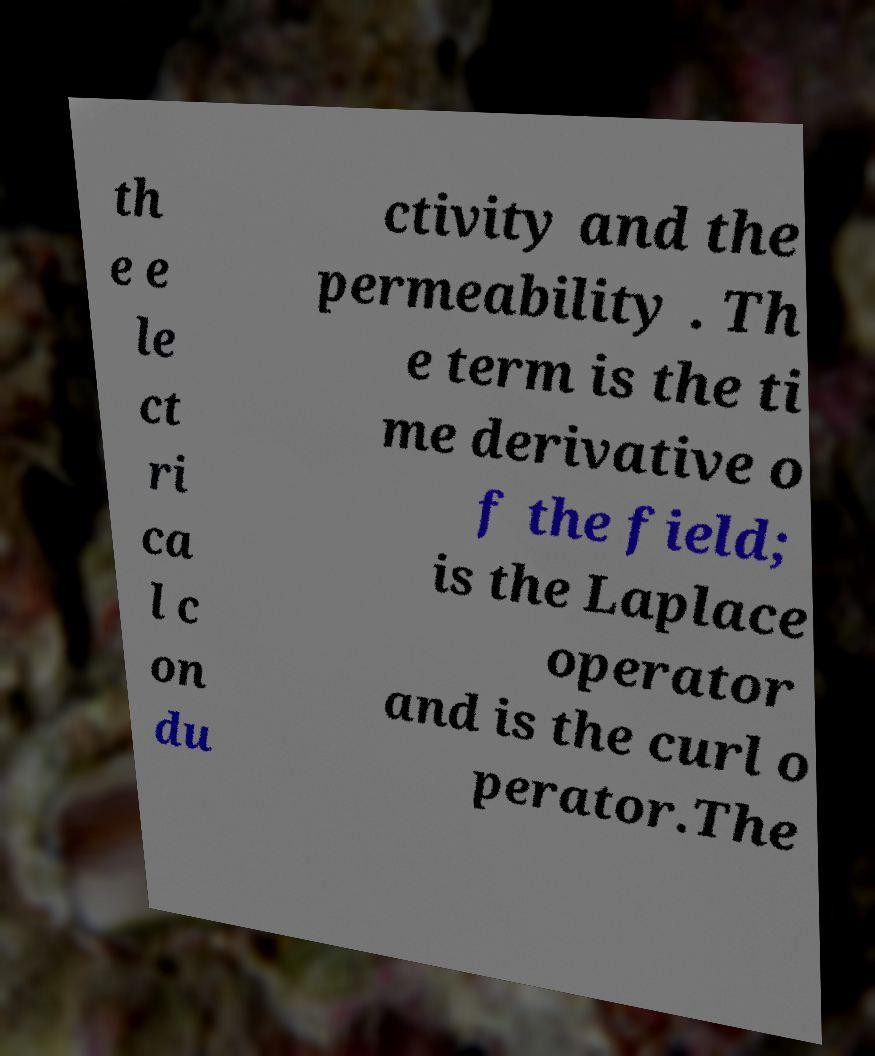Please identify and transcribe the text found in this image. th e e le ct ri ca l c on du ctivity and the permeability . Th e term is the ti me derivative o f the field; is the Laplace operator and is the curl o perator.The 